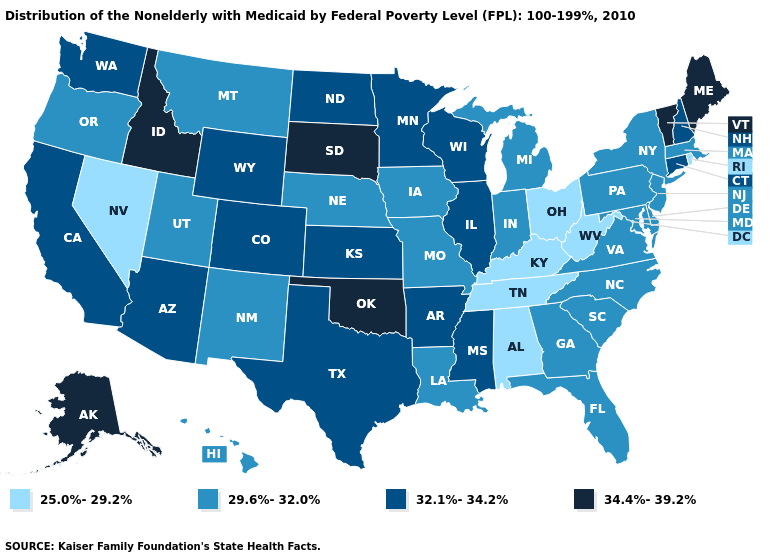Does Ohio have the lowest value in the USA?
Quick response, please. Yes. What is the value of Virginia?
Short answer required. 29.6%-32.0%. What is the value of North Carolina?
Give a very brief answer. 29.6%-32.0%. Does the first symbol in the legend represent the smallest category?
Be succinct. Yes. Which states hav the highest value in the West?
Short answer required. Alaska, Idaho. What is the value of New York?
Be succinct. 29.6%-32.0%. Does Michigan have the highest value in the MidWest?
Concise answer only. No. Does the first symbol in the legend represent the smallest category?
Quick response, please. Yes. What is the value of Vermont?
Be succinct. 34.4%-39.2%. Which states have the lowest value in the South?
Keep it brief. Alabama, Kentucky, Tennessee, West Virginia. Name the states that have a value in the range 32.1%-34.2%?
Keep it brief. Arizona, Arkansas, California, Colorado, Connecticut, Illinois, Kansas, Minnesota, Mississippi, New Hampshire, North Dakota, Texas, Washington, Wisconsin, Wyoming. What is the highest value in the USA?
Concise answer only. 34.4%-39.2%. What is the lowest value in states that border Oklahoma?
Give a very brief answer. 29.6%-32.0%. Does Michigan have the highest value in the MidWest?
Be succinct. No. Among the states that border Massachusetts , does New Hampshire have the highest value?
Concise answer only. No. 